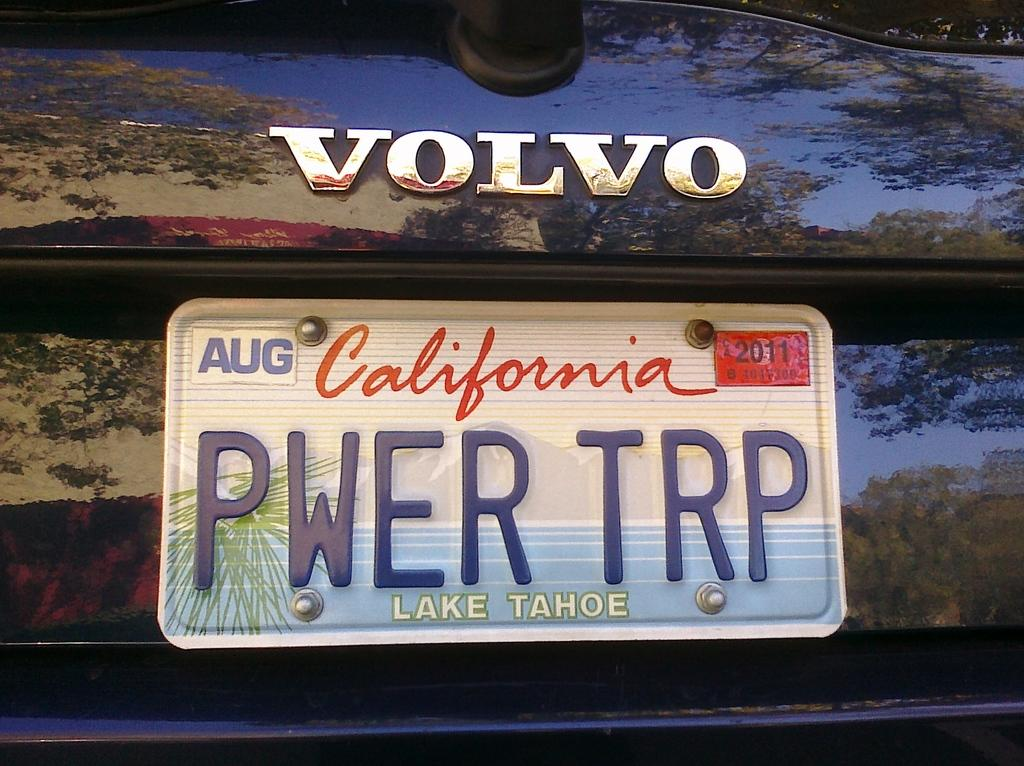<image>
Write a terse but informative summary of the picture. The registration shown is from Lake Tahoe in California. 